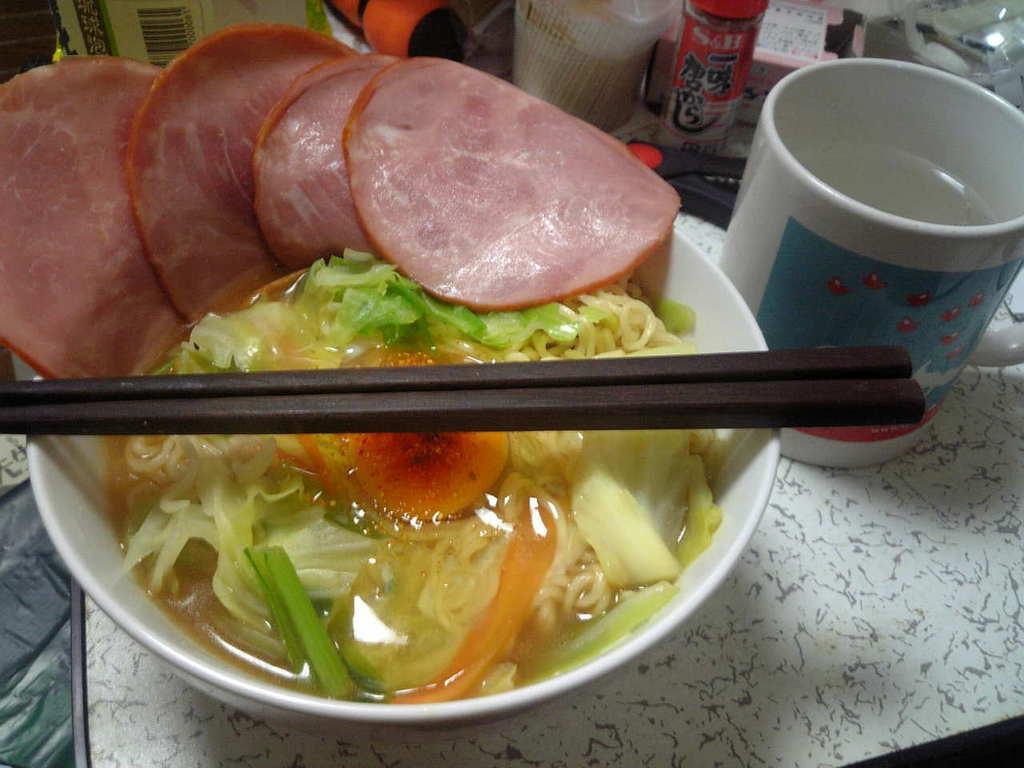Could you give a brief overview of what you see in this image? In the image we can see there is a food item in the bowl and there are chopsticks kept on the bowl. There is a meat dish kept on the bowl and there is a glass of cup kept on the table. Behind there are other objects kept on the table. 